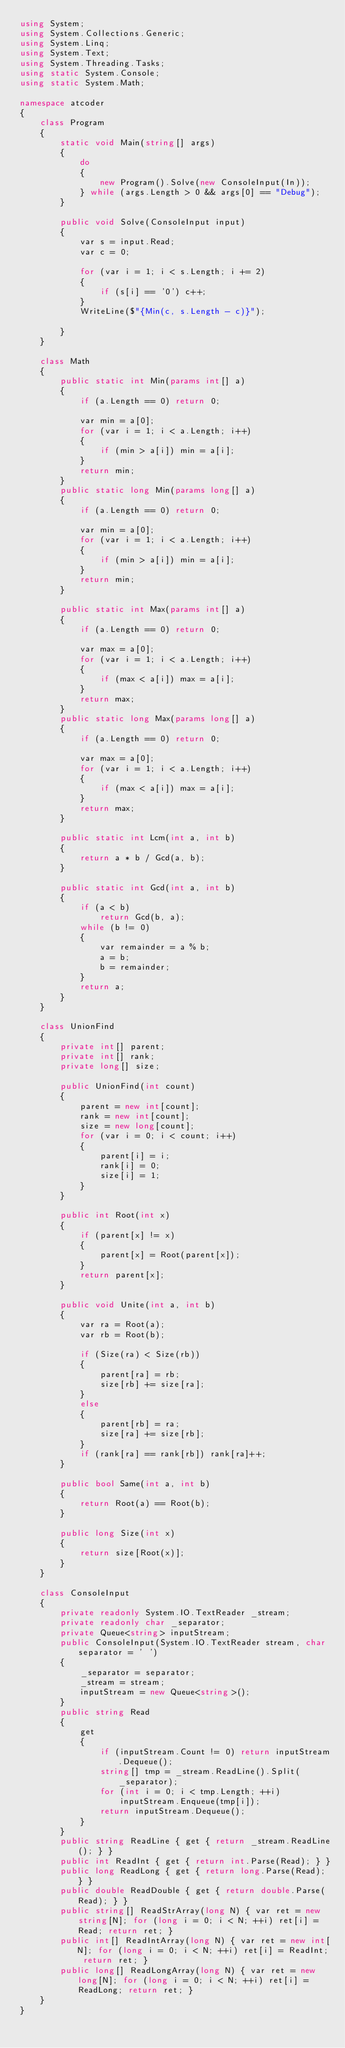<code> <loc_0><loc_0><loc_500><loc_500><_C#_>using System;
using System.Collections.Generic;
using System.Linq;
using System.Text;
using System.Threading.Tasks;
using static System.Console;
using static System.Math;

namespace atcoder
{
    class Program
    {
        static void Main(string[] args)
        {
            do
            {
                new Program().Solve(new ConsoleInput(In));
            } while (args.Length > 0 && args[0] == "Debug");
        }

        public void Solve(ConsoleInput input)
        {
            var s = input.Read;
            var c = 0;

            for (var i = 1; i < s.Length; i += 2)
            {
                if (s[i] == '0') c++;
            }
            WriteLine($"{Min(c, s.Length - c)}");

        }
    }

    class Math
    {
        public static int Min(params int[] a)
        {
            if (a.Length == 0) return 0;

            var min = a[0];
            for (var i = 1; i < a.Length; i++)
            {
                if (min > a[i]) min = a[i];
            }
            return min;
        }
        public static long Min(params long[] a)
        {
            if (a.Length == 0) return 0;

            var min = a[0];
            for (var i = 1; i < a.Length; i++)
            {
                if (min > a[i]) min = a[i];
            }
            return min;
        }

        public static int Max(params int[] a)
        {
            if (a.Length == 0) return 0;

            var max = a[0];
            for (var i = 1; i < a.Length; i++)
            {
                if (max < a[i]) max = a[i];
            }
            return max;
        }
        public static long Max(params long[] a)
        {
            if (a.Length == 0) return 0;

            var max = a[0];
            for (var i = 1; i < a.Length; i++)
            {
                if (max < a[i]) max = a[i];
            }
            return max;
        }

        public static int Lcm(int a, int b)
        {
            return a * b / Gcd(a, b);
        }

        public static int Gcd(int a, int b)
        {
            if (a < b)
                return Gcd(b, a);
            while (b != 0)
            {
                var remainder = a % b;
                a = b;
                b = remainder;
            }
            return a;
        }
    }

    class UnionFind
    {
        private int[] parent;
        private int[] rank;
        private long[] size;

        public UnionFind(int count)
        {
            parent = new int[count];
            rank = new int[count];
            size = new long[count];
            for (var i = 0; i < count; i++)
            {
                parent[i] = i;
                rank[i] = 0;
                size[i] = 1;
            }
        }

        public int Root(int x)
        {
            if (parent[x] != x)
            {
                parent[x] = Root(parent[x]);
            }
            return parent[x];
        }

        public void Unite(int a, int b)
        {
            var ra = Root(a);
            var rb = Root(b);

            if (Size(ra) < Size(rb))
            {
                parent[ra] = rb;
                size[rb] += size[ra];
            }
            else
            {
                parent[rb] = ra;
                size[ra] += size[rb];
            }
            if (rank[ra] == rank[rb]) rank[ra]++;
        }

        public bool Same(int a, int b)
        {
            return Root(a) == Root(b);
        }

        public long Size(int x)
        {
            return size[Root(x)];
        }
    }

    class ConsoleInput
    {
        private readonly System.IO.TextReader _stream;
        private readonly char _separator;
        private Queue<string> inputStream;
        public ConsoleInput(System.IO.TextReader stream, char separator = ' ')
        {
            _separator = separator;
            _stream = stream;
            inputStream = new Queue<string>();
        }
        public string Read
        {
            get
            {
                if (inputStream.Count != 0) return inputStream.Dequeue();
                string[] tmp = _stream.ReadLine().Split(_separator);
                for (int i = 0; i < tmp.Length; ++i)
                    inputStream.Enqueue(tmp[i]);
                return inputStream.Dequeue();
            }
        }
        public string ReadLine { get { return _stream.ReadLine(); } }
        public int ReadInt { get { return int.Parse(Read); } }
        public long ReadLong { get { return long.Parse(Read); } }
        public double ReadDouble { get { return double.Parse(Read); } }
        public string[] ReadStrArray(long N) { var ret = new string[N]; for (long i = 0; i < N; ++i) ret[i] = Read; return ret; }
        public int[] ReadIntArray(long N) { var ret = new int[N]; for (long i = 0; i < N; ++i) ret[i] = ReadInt; return ret; }
        public long[] ReadLongArray(long N) { var ret = new long[N]; for (long i = 0; i < N; ++i) ret[i] = ReadLong; return ret; }
    }
}
</code> 